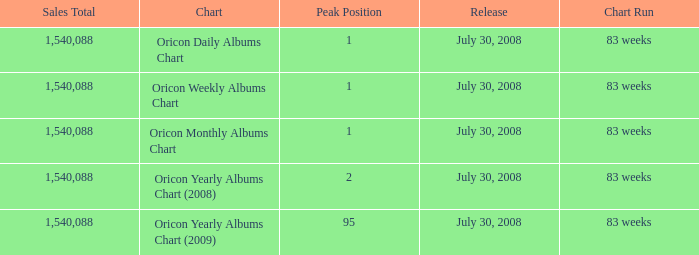Could you parse the entire table as a dict? {'header': ['Sales Total', 'Chart', 'Peak Position', 'Release', 'Chart Run'], 'rows': [['1,540,088', 'Oricon Daily Albums Chart', '1', 'July 30, 2008', '83 weeks'], ['1,540,088', 'Oricon Weekly Albums Chart', '1', 'July 30, 2008', '83 weeks'], ['1,540,088', 'Oricon Monthly Albums Chart', '1', 'July 30, 2008', '83 weeks'], ['1,540,088', 'Oricon Yearly Albums Chart (2008)', '2', 'July 30, 2008', '83 weeks'], ['1,540,088', 'Oricon Yearly Albums Chart (2009)', '95', 'July 30, 2008', '83 weeks']]} Which Sales Total has a Chart of oricon monthly albums chart? 1540088.0. 